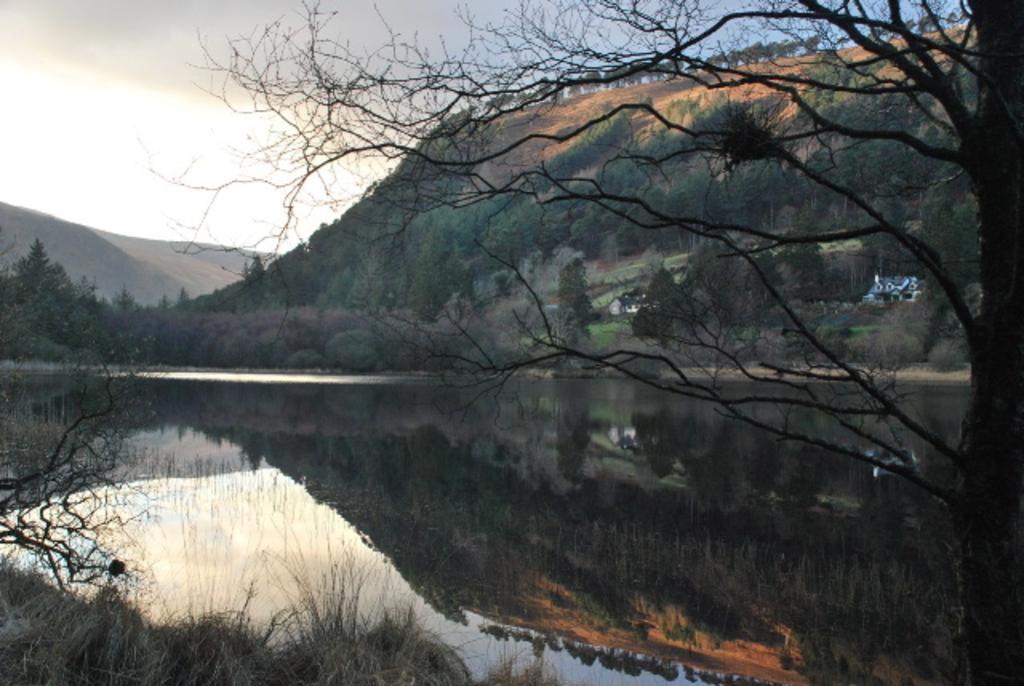Describe this image in one or two sentences. As we can see in the image there is water, dry grass, trees and hills. In the background there is a house. On the top there is a sky. 